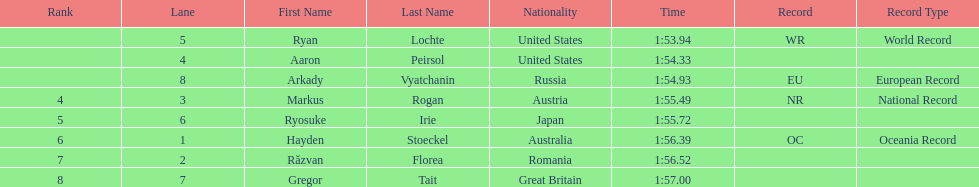How long did it take ryosuke irie to finish? 1:55.72. 